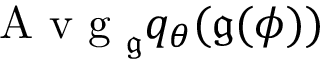Convert formula to latex. <formula><loc_0><loc_0><loc_500><loc_500>A v g _ { \mathfrak { g } } q _ { \theta } ( \mathfrak { g } ( \phi ) )</formula> 